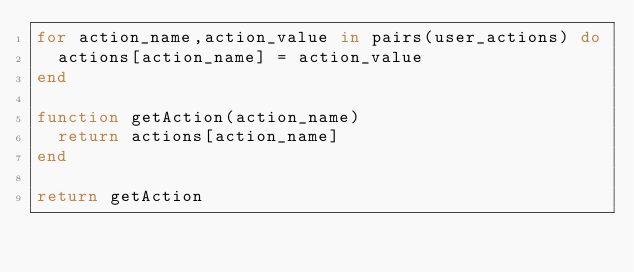<code> <loc_0><loc_0><loc_500><loc_500><_Lua_>for action_name,action_value in pairs(user_actions) do
  actions[action_name] = action_value
end

function getAction(action_name)
  return actions[action_name]
end

return getAction
</code> 